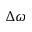<formula> <loc_0><loc_0><loc_500><loc_500>\Delta \omega</formula> 